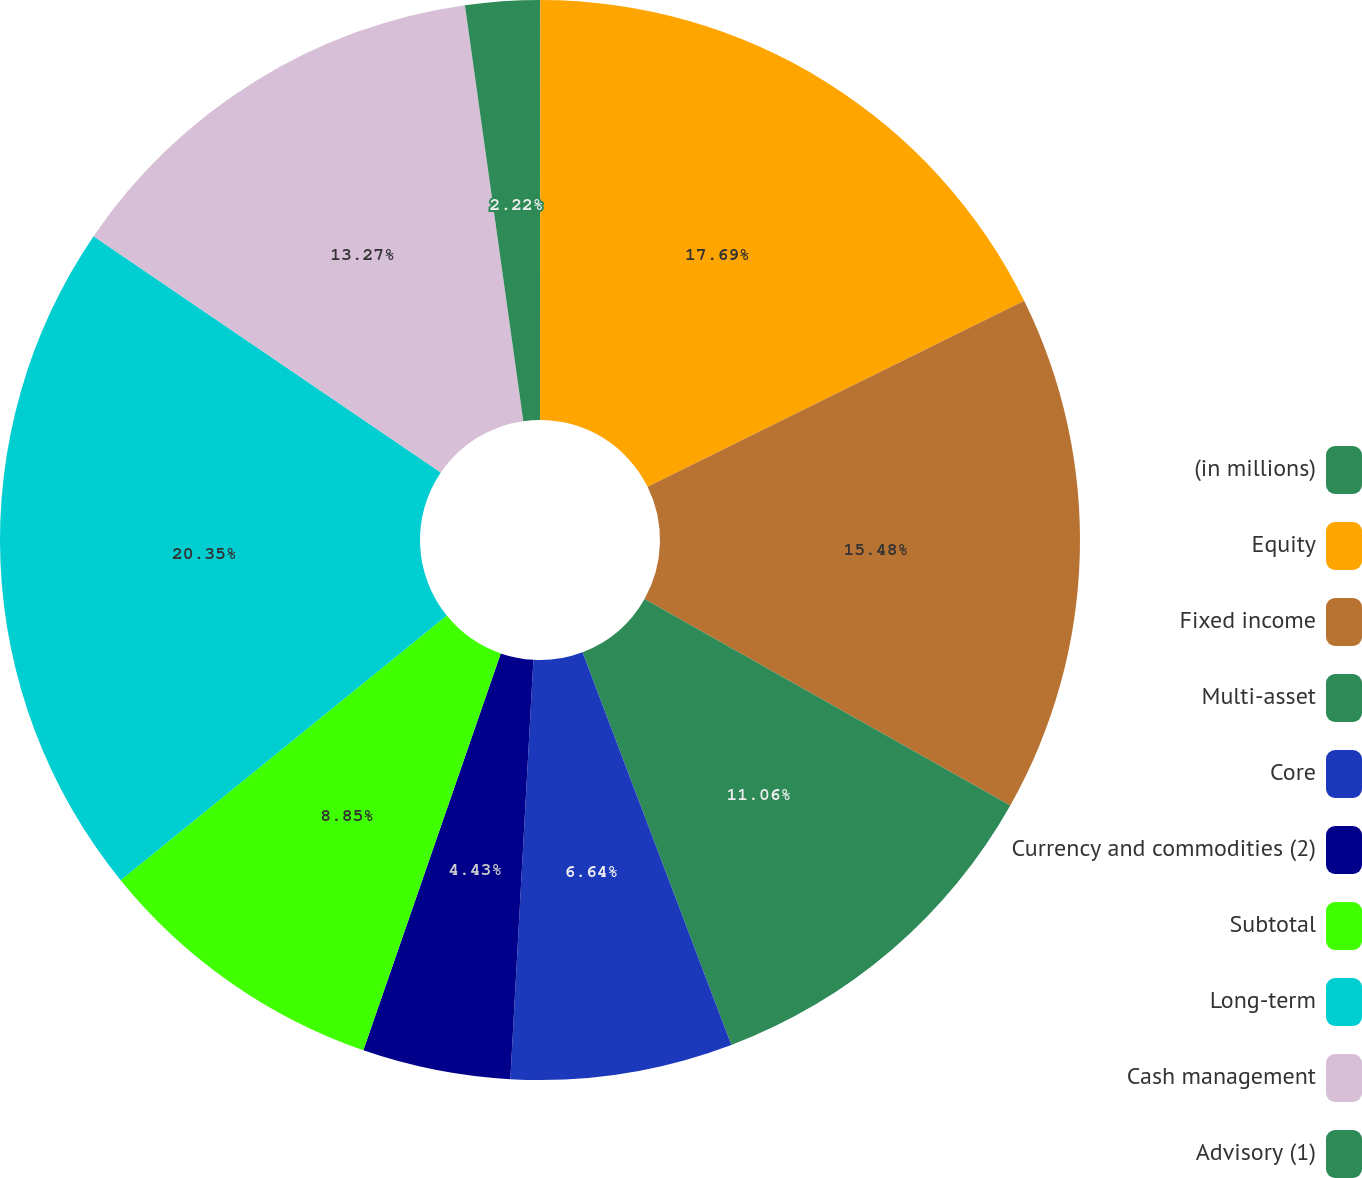Convert chart. <chart><loc_0><loc_0><loc_500><loc_500><pie_chart><fcel>(in millions)<fcel>Equity<fcel>Fixed income<fcel>Multi-asset<fcel>Core<fcel>Currency and commodities (2)<fcel>Subtotal<fcel>Long-term<fcel>Cash management<fcel>Advisory (1)<nl><fcel>0.01%<fcel>17.69%<fcel>15.48%<fcel>11.06%<fcel>6.64%<fcel>4.43%<fcel>8.85%<fcel>20.36%<fcel>13.27%<fcel>2.22%<nl></chart> 